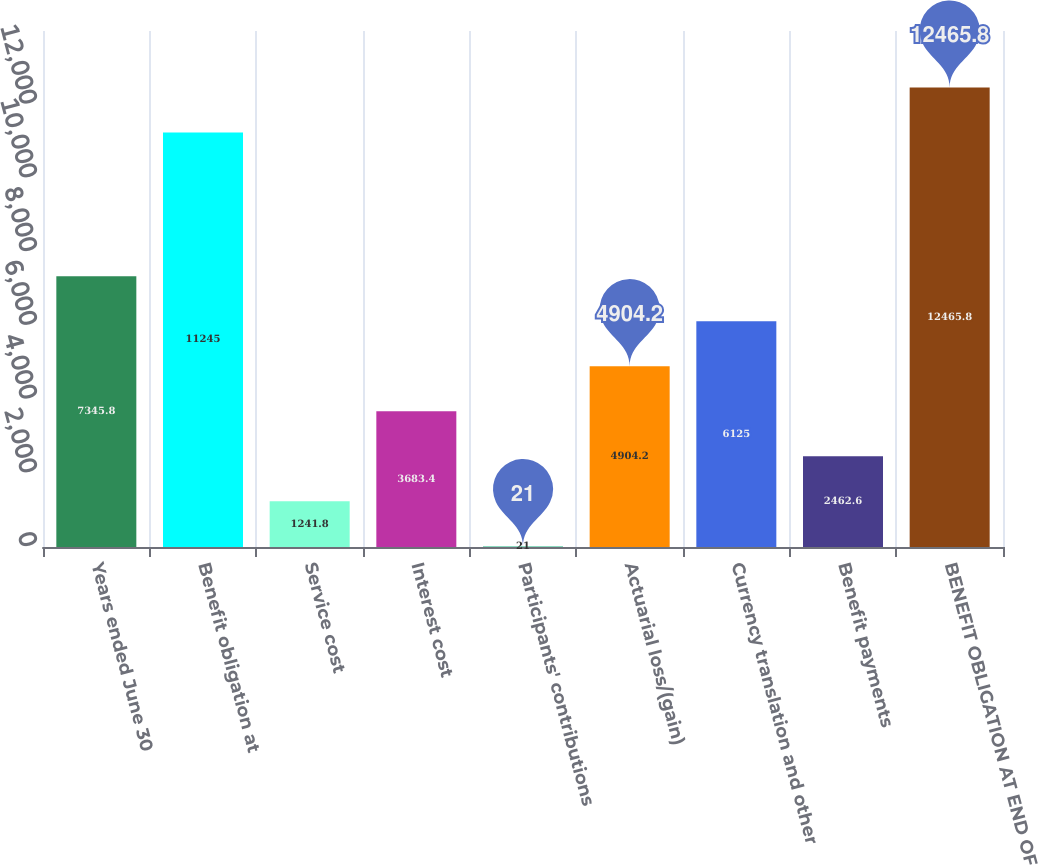Convert chart. <chart><loc_0><loc_0><loc_500><loc_500><bar_chart><fcel>Years ended June 30<fcel>Benefit obligation at<fcel>Service cost<fcel>Interest cost<fcel>Participants' contributions<fcel>Actuarial loss/(gain)<fcel>Currency translation and other<fcel>Benefit payments<fcel>BENEFIT OBLIGATION AT END OF<nl><fcel>7345.8<fcel>11245<fcel>1241.8<fcel>3683.4<fcel>21<fcel>4904.2<fcel>6125<fcel>2462.6<fcel>12465.8<nl></chart> 